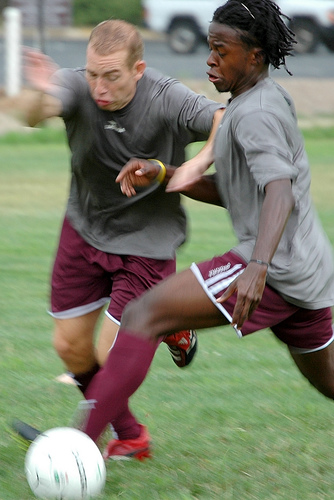<image>
Is the ball on the grass? Yes. Looking at the image, I can see the ball is positioned on top of the grass, with the grass providing support. Is the man under the black man? No. The man is not positioned under the black man. The vertical relationship between these objects is different. Is there a man behind the man? Yes. From this viewpoint, the man is positioned behind the man, with the man partially or fully occluding the man. 